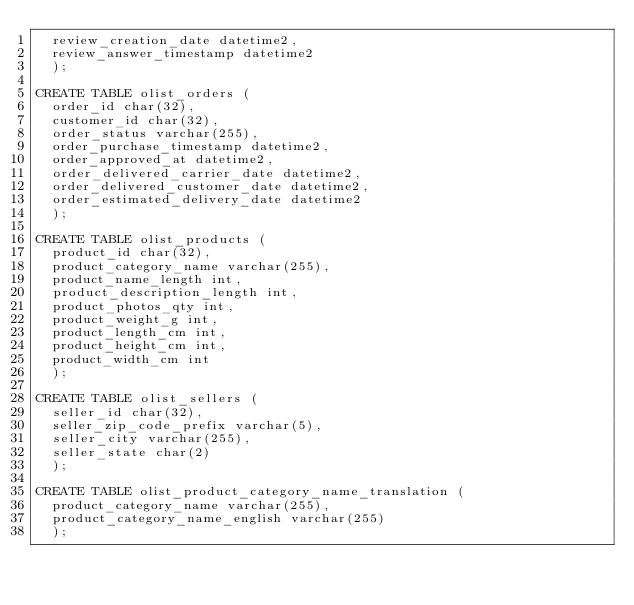<code> <loc_0><loc_0><loc_500><loc_500><_SQL_>	review_creation_date datetime2,
	review_answer_timestamp datetime2
	);

CREATE TABLE olist_orders (
	order_id char(32),
	customer_id char(32),
	order_status varchar(255),
	order_purchase_timestamp datetime2,
	order_approved_at datetime2,
	order_delivered_carrier_date datetime2,
	order_delivered_customer_date datetime2,
	order_estimated_delivery_date datetime2
	);

CREATE TABLE olist_products (
	product_id char(32),
	product_category_name varchar(255),	
	product_name_length int,
	product_description_length int,
	product_photos_qty int,
	product_weight_g int,	
	product_length_cm int,	
	product_height_cm int,
	product_width_cm int
	);

CREATE TABLE olist_sellers (
	seller_id char(32),
	seller_zip_code_prefix varchar(5),
	seller_city varchar(255),
	seller_state char(2)
	);

CREATE TABLE olist_product_category_name_translation (
	product_category_name varchar(255),
	product_category_name_english varchar(255)
	);
</code> 